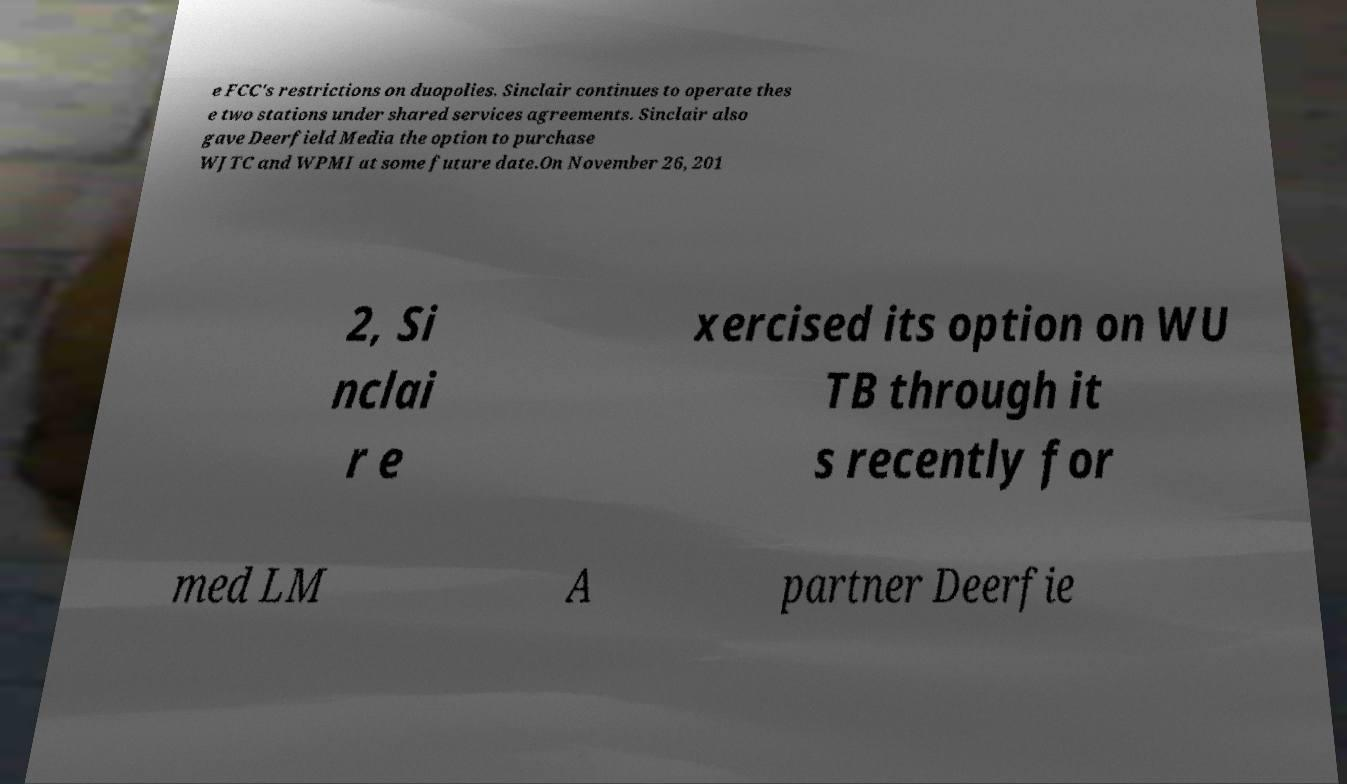For documentation purposes, I need the text within this image transcribed. Could you provide that? e FCC's restrictions on duopolies. Sinclair continues to operate thes e two stations under shared services agreements. Sinclair also gave Deerfield Media the option to purchase WJTC and WPMI at some future date.On November 26, 201 2, Si nclai r e xercised its option on WU TB through it s recently for med LM A partner Deerfie 